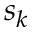Convert formula to latex. <formula><loc_0><loc_0><loc_500><loc_500>s _ { k }</formula> 